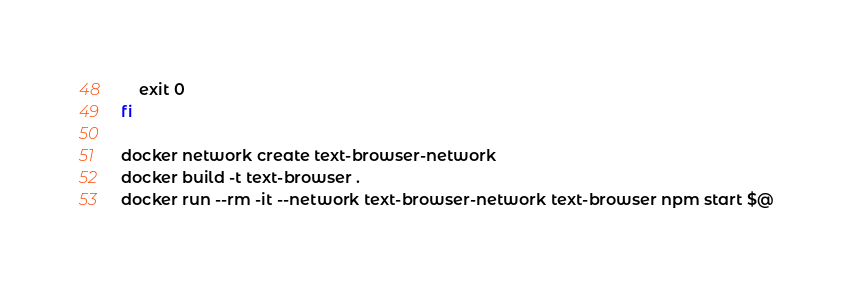<code> <loc_0><loc_0><loc_500><loc_500><_Bash_>	exit 0
fi

docker network create text-browser-network
docker build -t text-browser .
docker run --rm -it --network text-browser-network text-browser npm start $@
</code> 